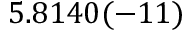Convert formula to latex. <formula><loc_0><loc_0><loc_500><loc_500>5 . 8 1 4 0 ( - 1 1 )</formula> 